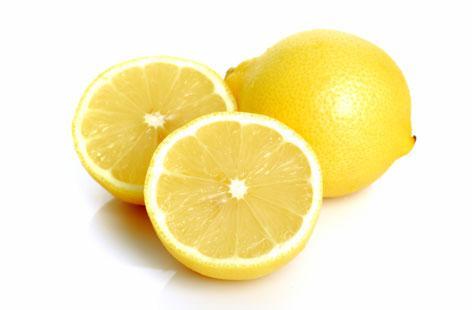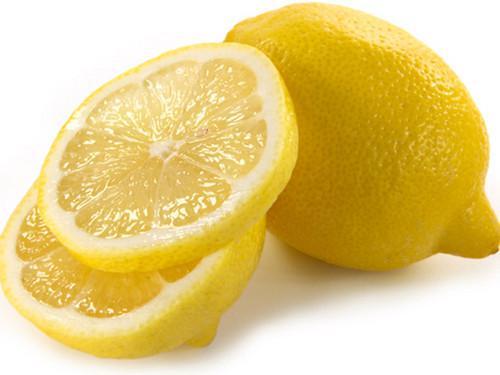The first image is the image on the left, the second image is the image on the right. Assess this claim about the two images: "Both images contain cut lemons.". Correct or not? Answer yes or no. Yes. 